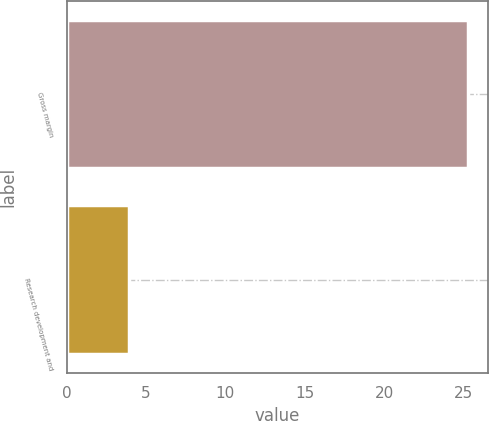Convert chart to OTSL. <chart><loc_0><loc_0><loc_500><loc_500><bar_chart><fcel>Gross margin<fcel>Research development and<nl><fcel>25.3<fcel>3.9<nl></chart> 